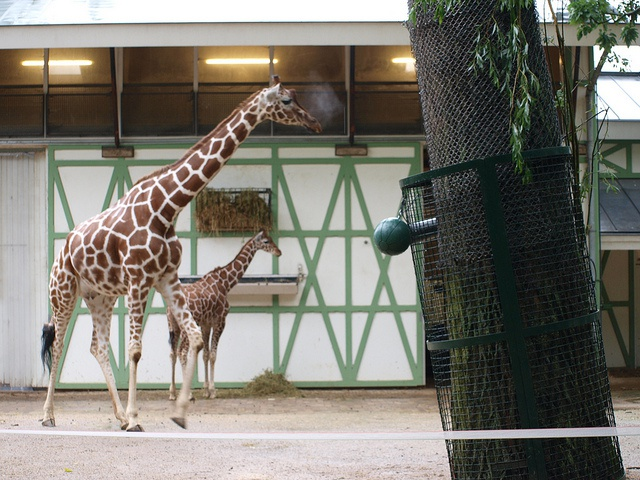Describe the objects in this image and their specific colors. I can see giraffe in lightblue, darkgray, lightgray, gray, and maroon tones and giraffe in lightblue, gray, maroon, and darkgray tones in this image. 